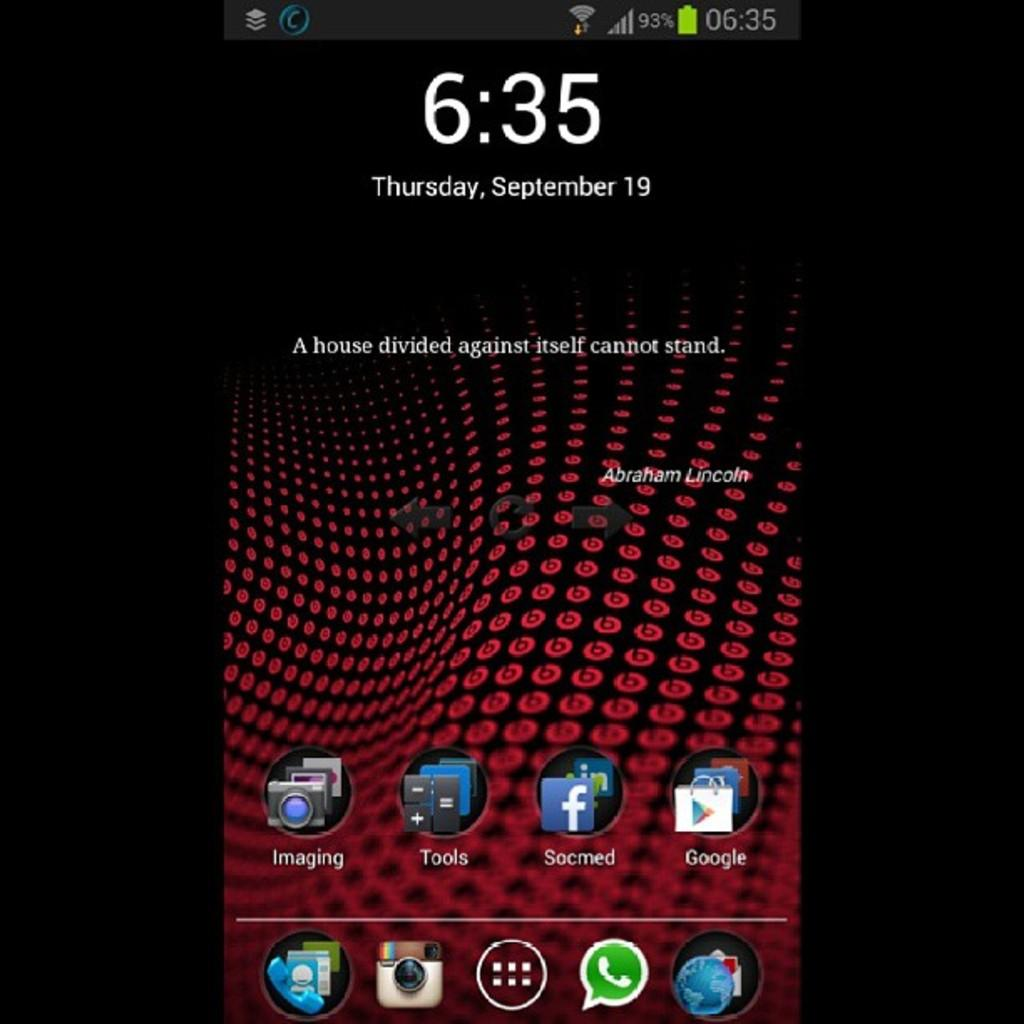<image>
Present a compact description of the photo's key features. a screenshot of a phonebackground with the quite, " a house divided against itself cannot stand". 